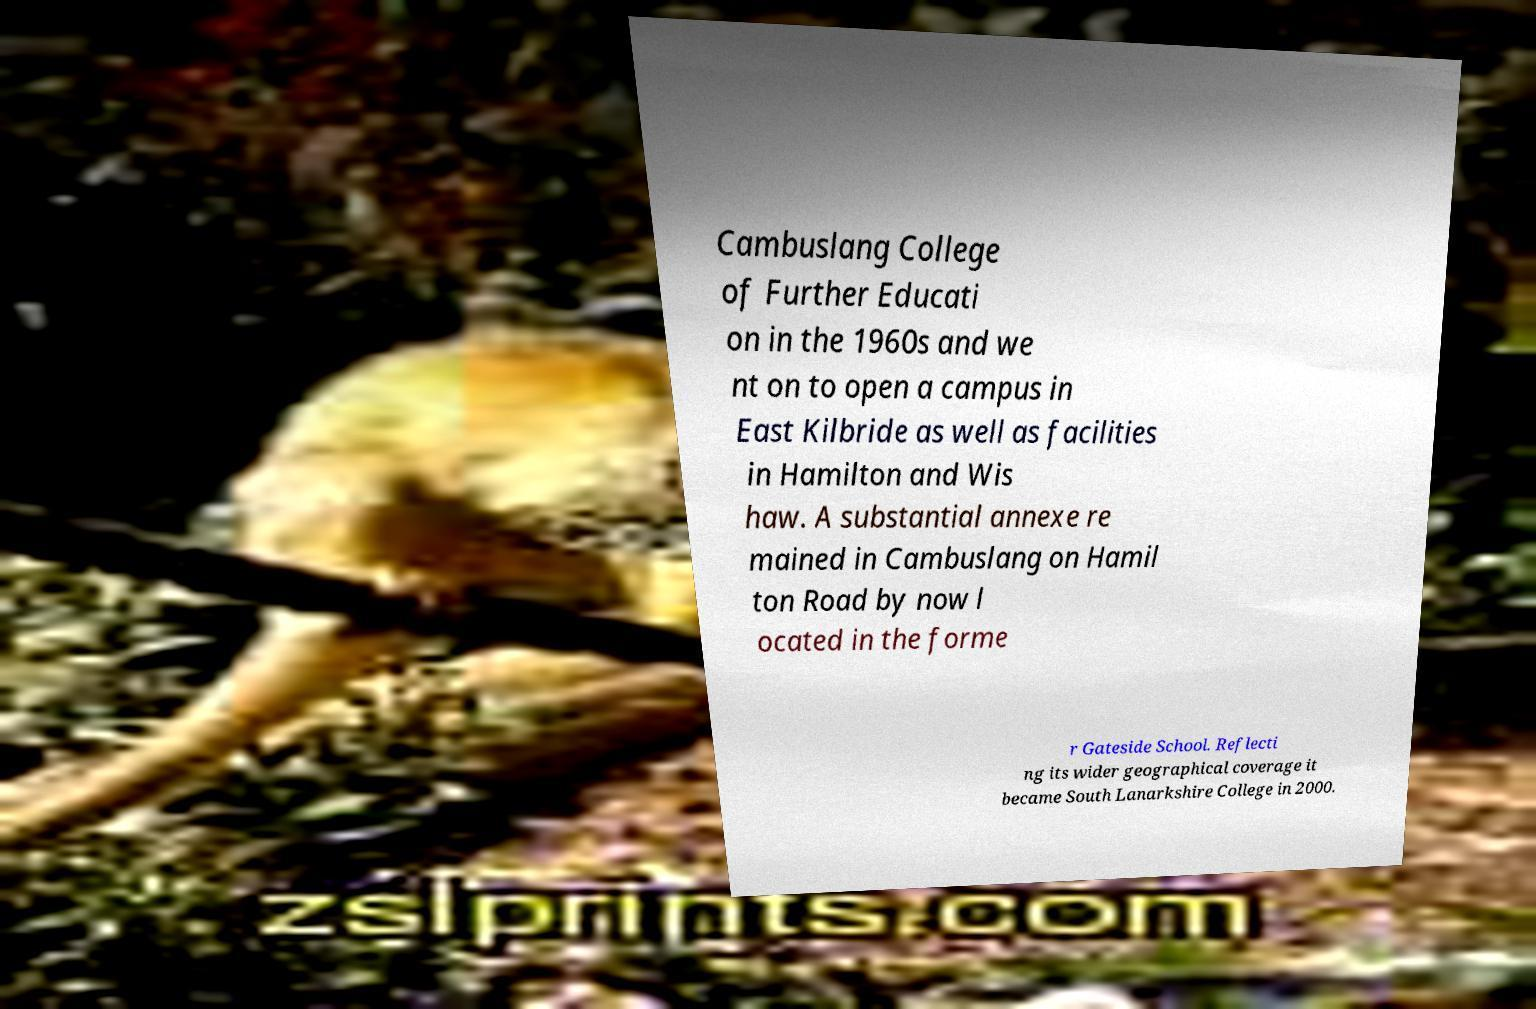Could you assist in decoding the text presented in this image and type it out clearly? Cambuslang College of Further Educati on in the 1960s and we nt on to open a campus in East Kilbride as well as facilities in Hamilton and Wis haw. A substantial annexe re mained in Cambuslang on Hamil ton Road by now l ocated in the forme r Gateside School. Reflecti ng its wider geographical coverage it became South Lanarkshire College in 2000. 